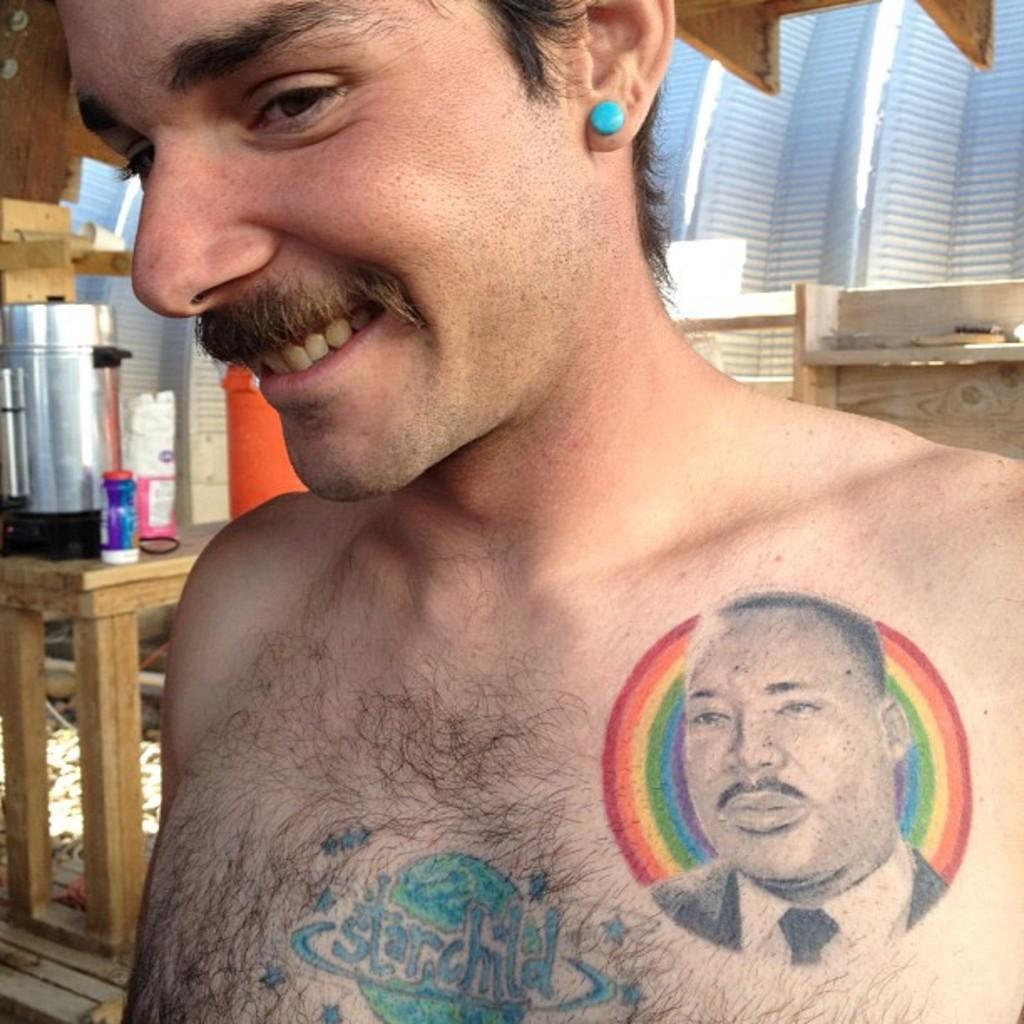Describe this image in one or two sentences. In this picture I can see a man in front and I see that he is smiling. I can also see 2 tattoos on his chest. In the background I can see a table on which there are few things and on the right side of this picture I can see a brown color thing. 